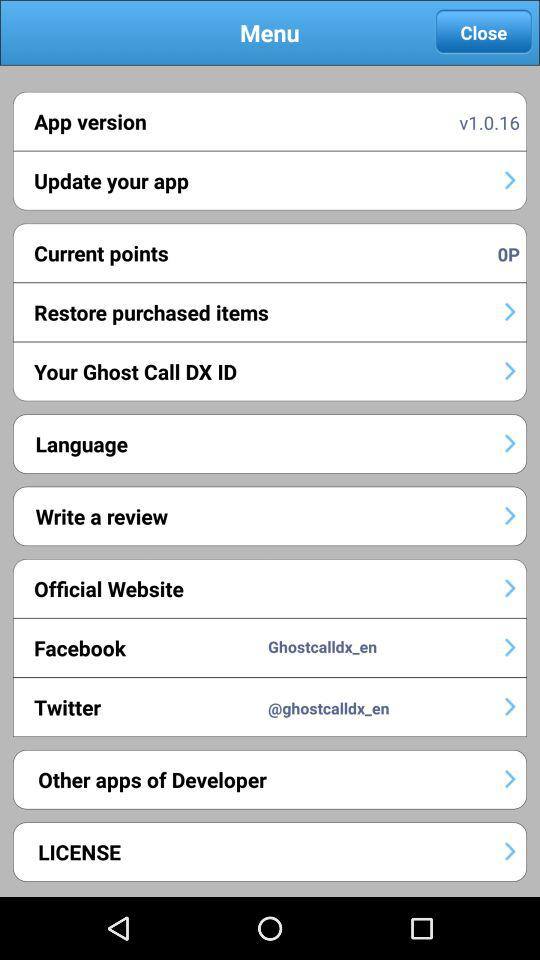What is the username used on "Twitter"? The username is "@ghostcalldx_en". 